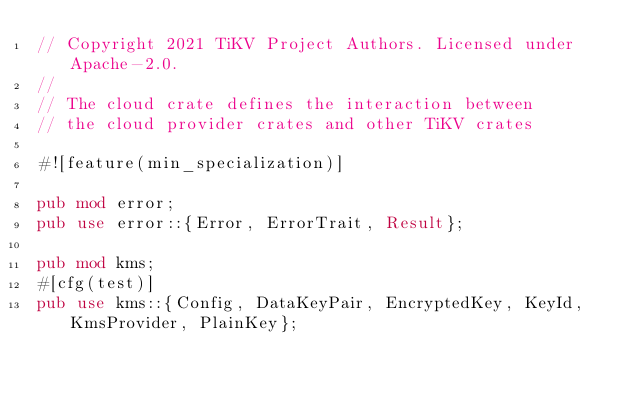Convert code to text. <code><loc_0><loc_0><loc_500><loc_500><_Rust_>// Copyright 2021 TiKV Project Authors. Licensed under Apache-2.0.
//
// The cloud crate defines the interaction between
// the cloud provider crates and other TiKV crates

#![feature(min_specialization)]

pub mod error;
pub use error::{Error, ErrorTrait, Result};

pub mod kms;
#[cfg(test)]
pub use kms::{Config, DataKeyPair, EncryptedKey, KeyId, KmsProvider, PlainKey};
</code> 